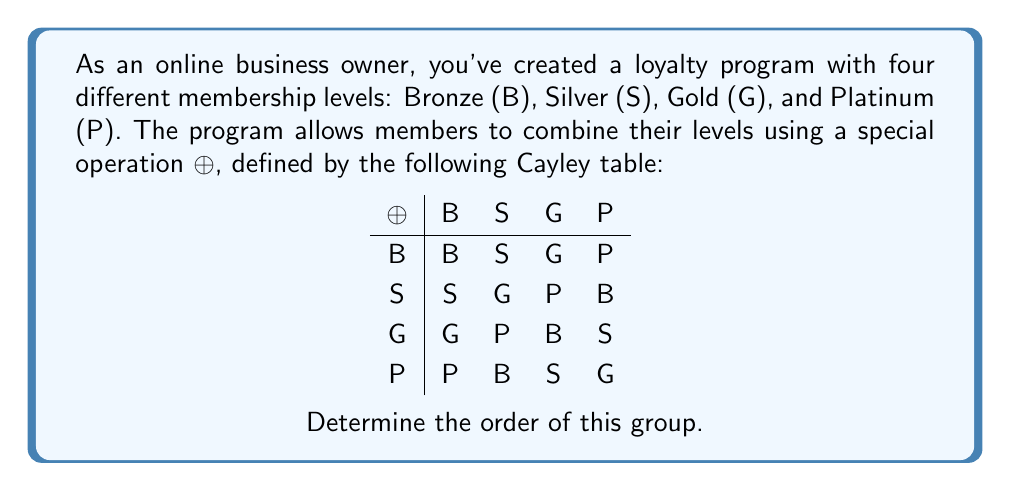What is the answer to this math problem? To determine the order of this finite group, we need to follow these steps:

1) First, we need to verify that this is indeed a group:
   - Closure: The table shows that the result of any two elements combined is always within the set {B, S, G, P}.
   - Associativity: This is assumed for finite groups defined by Cayley tables.
   - Identity element: B acts as the identity, as B ⊕ X = X ⊕ B = X for all X.
   - Inverse elements: Each element is its own inverse (e.g., S ⊕ S = G, G ⊕ G = B).

2) Now that we've confirmed it's a group, we can determine its order:
   - The order of a finite group is simply the number of elements in the group.
   - From the Cayley table, we can see that there are 4 distinct elements: B, S, G, and P.

3) Therefore, the order of this group is 4.

Note: This group is isomorphic to the cyclic group $C_4$ or $\mathbb{Z}_4$, which represents the rotational symmetries of a square.
Answer: 4 